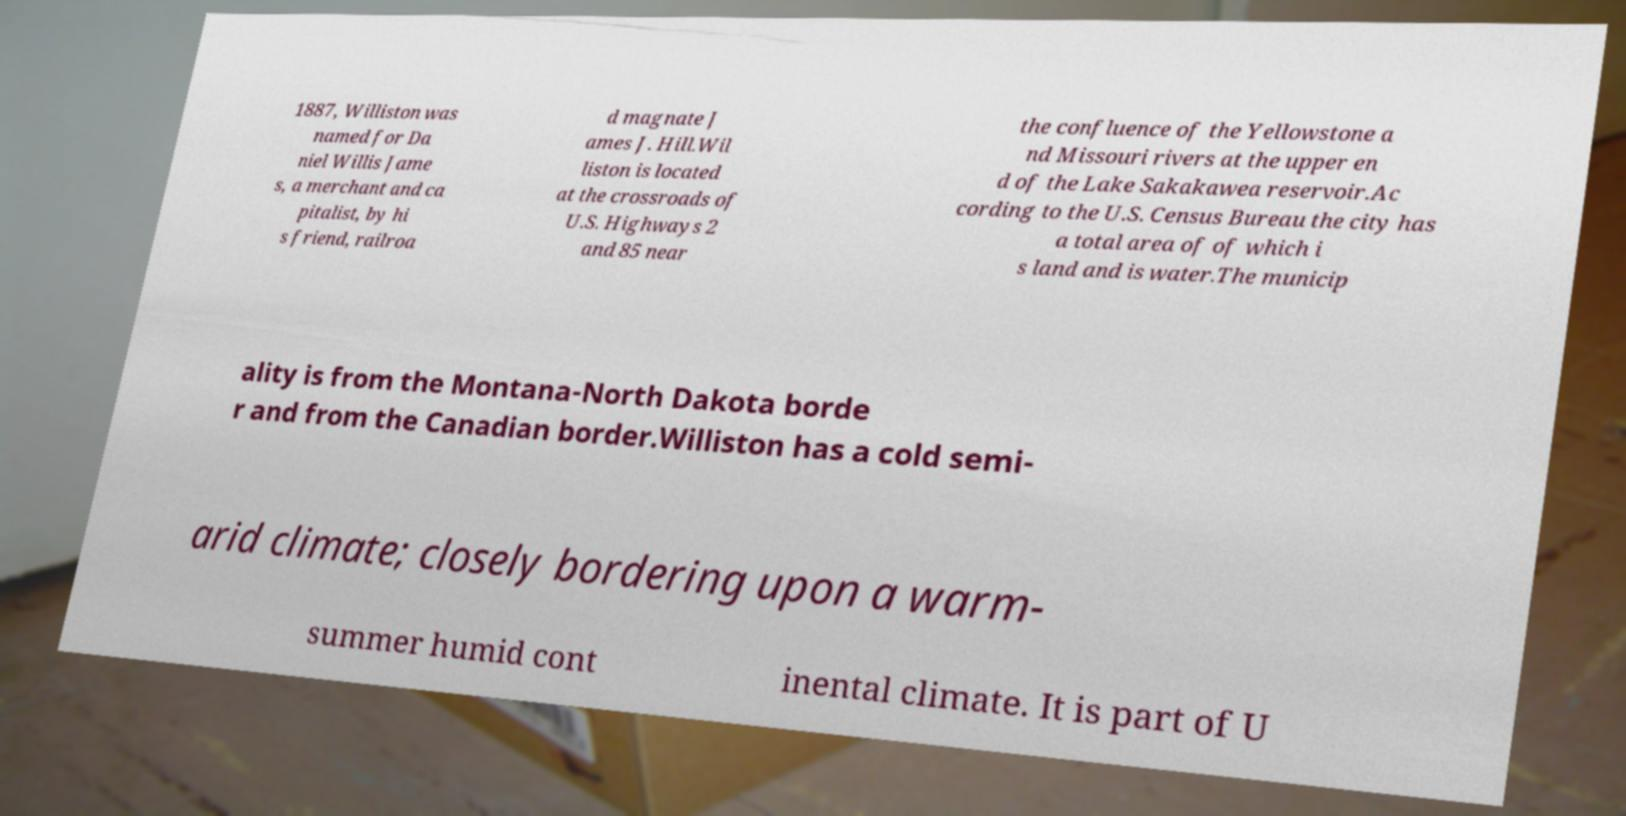Please read and relay the text visible in this image. What does it say? 1887, Williston was named for Da niel Willis Jame s, a merchant and ca pitalist, by hi s friend, railroa d magnate J ames J. Hill.Wil liston is located at the crossroads of U.S. Highways 2 and 85 near the confluence of the Yellowstone a nd Missouri rivers at the upper en d of the Lake Sakakawea reservoir.Ac cording to the U.S. Census Bureau the city has a total area of of which i s land and is water.The municip ality is from the Montana-North Dakota borde r and from the Canadian border.Williston has a cold semi- arid climate; closely bordering upon a warm- summer humid cont inental climate. It is part of U 